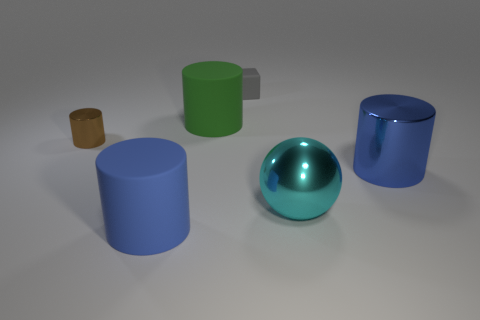Subtract 1 cylinders. How many cylinders are left? 3 Add 3 small purple rubber cubes. How many objects exist? 9 Subtract all spheres. How many objects are left? 5 Add 2 cyan blocks. How many cyan blocks exist? 2 Subtract 0 yellow cylinders. How many objects are left? 6 Subtract all big yellow metal cylinders. Subtract all small gray matte things. How many objects are left? 5 Add 1 big green cylinders. How many big green cylinders are left? 2 